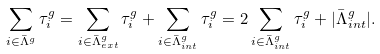Convert formula to latex. <formula><loc_0><loc_0><loc_500><loc_500>\sum _ { i \in \bar { \Lambda } ^ { g } } \tau _ { i } ^ { g } = \sum _ { i \in \bar { \Lambda } _ { e x t } ^ { g } } \tau _ { i } ^ { g } + \sum _ { i \in \bar { \Lambda } _ { i n t } ^ { g } } \tau _ { i } ^ { g } = 2 \sum _ { i \in \bar { \Lambda } _ { i n t } ^ { g } } \tau _ { i } ^ { g } + | \bar { \Lambda } _ { i n t } ^ { g } | .</formula> 